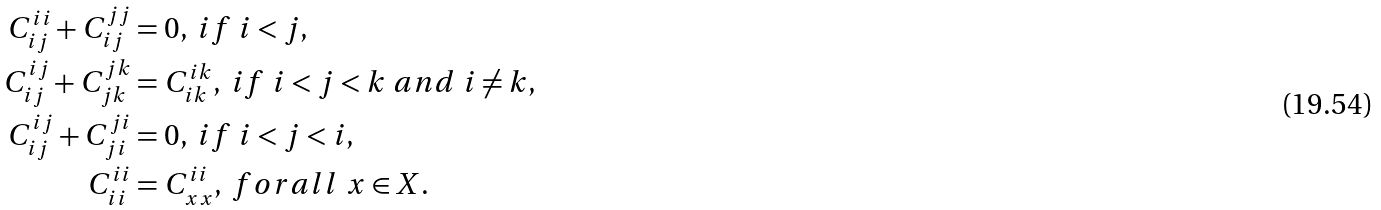Convert formula to latex. <formula><loc_0><loc_0><loc_500><loc_500>C _ { i j } ^ { i i } + C _ { i j } ^ { j j } & = 0 , \ i f \ i < j , \\ C _ { i j } ^ { i j } + C _ { j k } ^ { j k } & = C _ { i k } ^ { i k } , \ i f \ i < j < k \ a n d \ i \ne k , \\ C _ { i j } ^ { i j } + C _ { j i } ^ { j i } & = 0 , \ i f \ i < j < i , \\ C _ { i i } ^ { i i } & = C _ { x x } ^ { i i } , \ f o r a l l \ x \in X .</formula> 